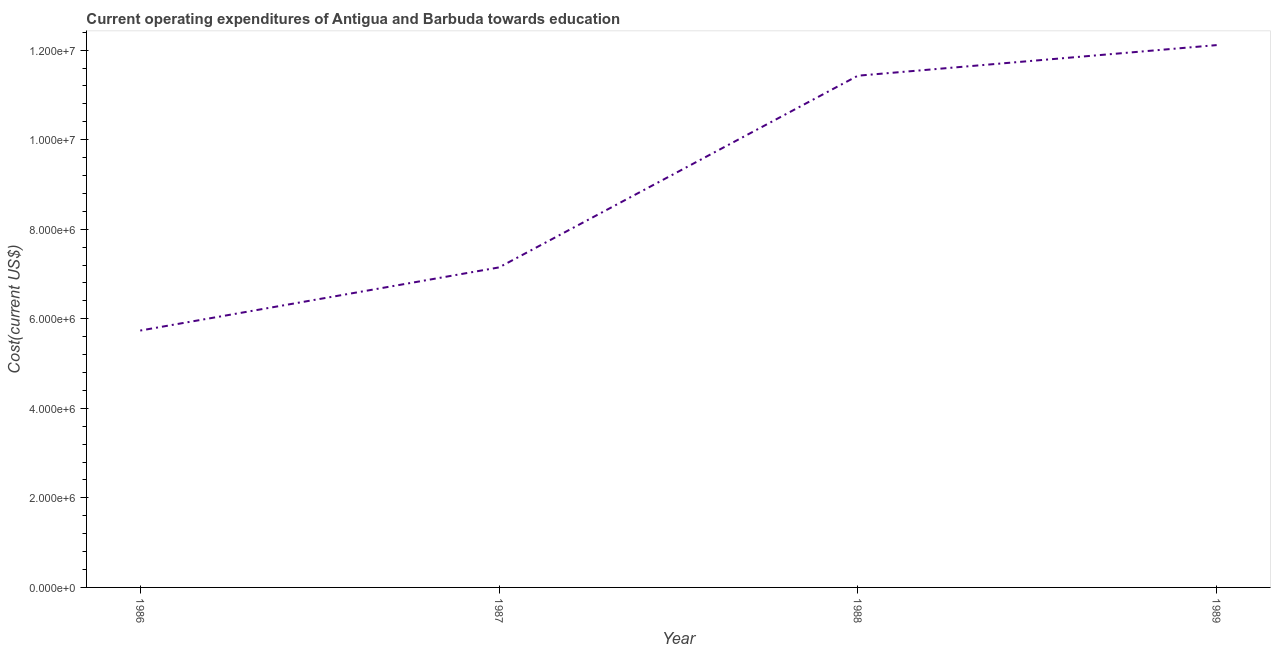What is the education expenditure in 1986?
Your response must be concise. 5.74e+06. Across all years, what is the maximum education expenditure?
Offer a very short reply. 1.21e+07. Across all years, what is the minimum education expenditure?
Your answer should be compact. 5.74e+06. In which year was the education expenditure maximum?
Ensure brevity in your answer.  1989. What is the sum of the education expenditure?
Make the answer very short. 3.64e+07. What is the difference between the education expenditure in 1987 and 1988?
Keep it short and to the point. -4.28e+06. What is the average education expenditure per year?
Make the answer very short. 9.11e+06. What is the median education expenditure?
Keep it short and to the point. 9.29e+06. In how many years, is the education expenditure greater than 3600000 US$?
Make the answer very short. 4. Do a majority of the years between 1987 and 1986 (inclusive) have education expenditure greater than 6000000 US$?
Offer a terse response. No. What is the ratio of the education expenditure in 1986 to that in 1987?
Your answer should be very brief. 0.8. Is the education expenditure in 1987 less than that in 1988?
Provide a short and direct response. Yes. What is the difference between the highest and the second highest education expenditure?
Offer a very short reply. 6.84e+05. What is the difference between the highest and the lowest education expenditure?
Your answer should be compact. 6.38e+06. How many lines are there?
Provide a succinct answer. 1. What is the difference between two consecutive major ticks on the Y-axis?
Offer a very short reply. 2.00e+06. Are the values on the major ticks of Y-axis written in scientific E-notation?
Make the answer very short. Yes. Does the graph contain grids?
Make the answer very short. No. What is the title of the graph?
Your answer should be very brief. Current operating expenditures of Antigua and Barbuda towards education. What is the label or title of the X-axis?
Offer a very short reply. Year. What is the label or title of the Y-axis?
Keep it short and to the point. Cost(current US$). What is the Cost(current US$) of 1986?
Provide a short and direct response. 5.74e+06. What is the Cost(current US$) in 1987?
Your answer should be very brief. 7.15e+06. What is the Cost(current US$) in 1988?
Offer a terse response. 1.14e+07. What is the Cost(current US$) of 1989?
Keep it short and to the point. 1.21e+07. What is the difference between the Cost(current US$) in 1986 and 1987?
Your response must be concise. -1.41e+06. What is the difference between the Cost(current US$) in 1986 and 1988?
Your response must be concise. -5.69e+06. What is the difference between the Cost(current US$) in 1986 and 1989?
Make the answer very short. -6.38e+06. What is the difference between the Cost(current US$) in 1987 and 1988?
Your answer should be very brief. -4.28e+06. What is the difference between the Cost(current US$) in 1987 and 1989?
Your answer should be compact. -4.97e+06. What is the difference between the Cost(current US$) in 1988 and 1989?
Offer a terse response. -6.84e+05. What is the ratio of the Cost(current US$) in 1986 to that in 1987?
Your response must be concise. 0.8. What is the ratio of the Cost(current US$) in 1986 to that in 1988?
Your response must be concise. 0.5. What is the ratio of the Cost(current US$) in 1986 to that in 1989?
Offer a very short reply. 0.47. What is the ratio of the Cost(current US$) in 1987 to that in 1989?
Your answer should be very brief. 0.59. What is the ratio of the Cost(current US$) in 1988 to that in 1989?
Your answer should be compact. 0.94. 